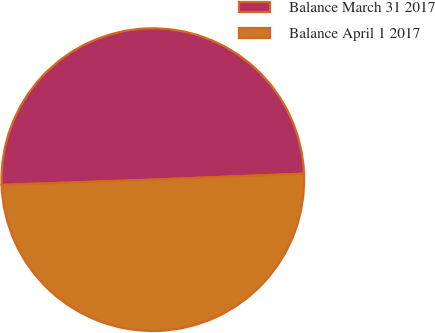Convert chart. <chart><loc_0><loc_0><loc_500><loc_500><pie_chart><fcel>Balance March 31 2017<fcel>Balance April 1 2017<nl><fcel>49.92%<fcel>50.08%<nl></chart> 